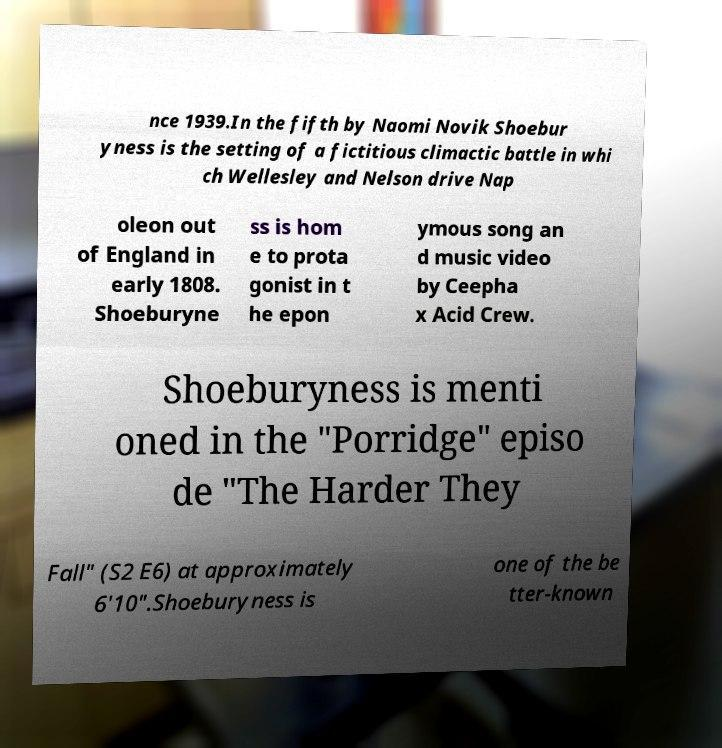What messages or text are displayed in this image? I need them in a readable, typed format. nce 1939.In the fifth by Naomi Novik Shoebur yness is the setting of a fictitious climactic battle in whi ch Wellesley and Nelson drive Nap oleon out of England in early 1808. Shoeburyne ss is hom e to prota gonist in t he epon ymous song an d music video by Ceepha x Acid Crew. Shoeburyness is menti oned in the "Porridge" episo de "The Harder They Fall" (S2 E6) at approximately 6'10".Shoeburyness is one of the be tter-known 